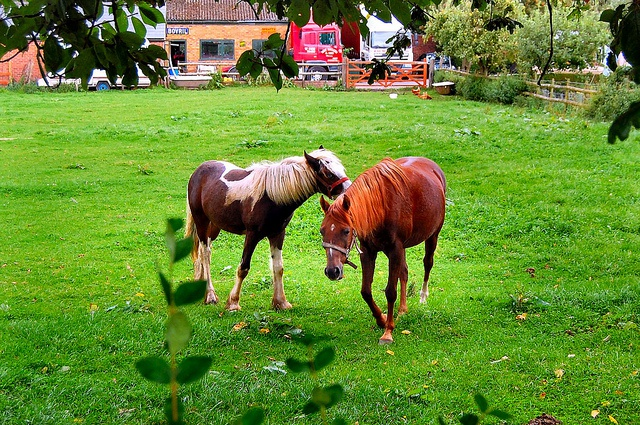Describe the objects in this image and their specific colors. I can see horse in green, black, maroon, brown, and red tones, horse in green, black, lavender, maroon, and gray tones, and truck in green, salmon, violet, lavender, and lightpink tones in this image. 